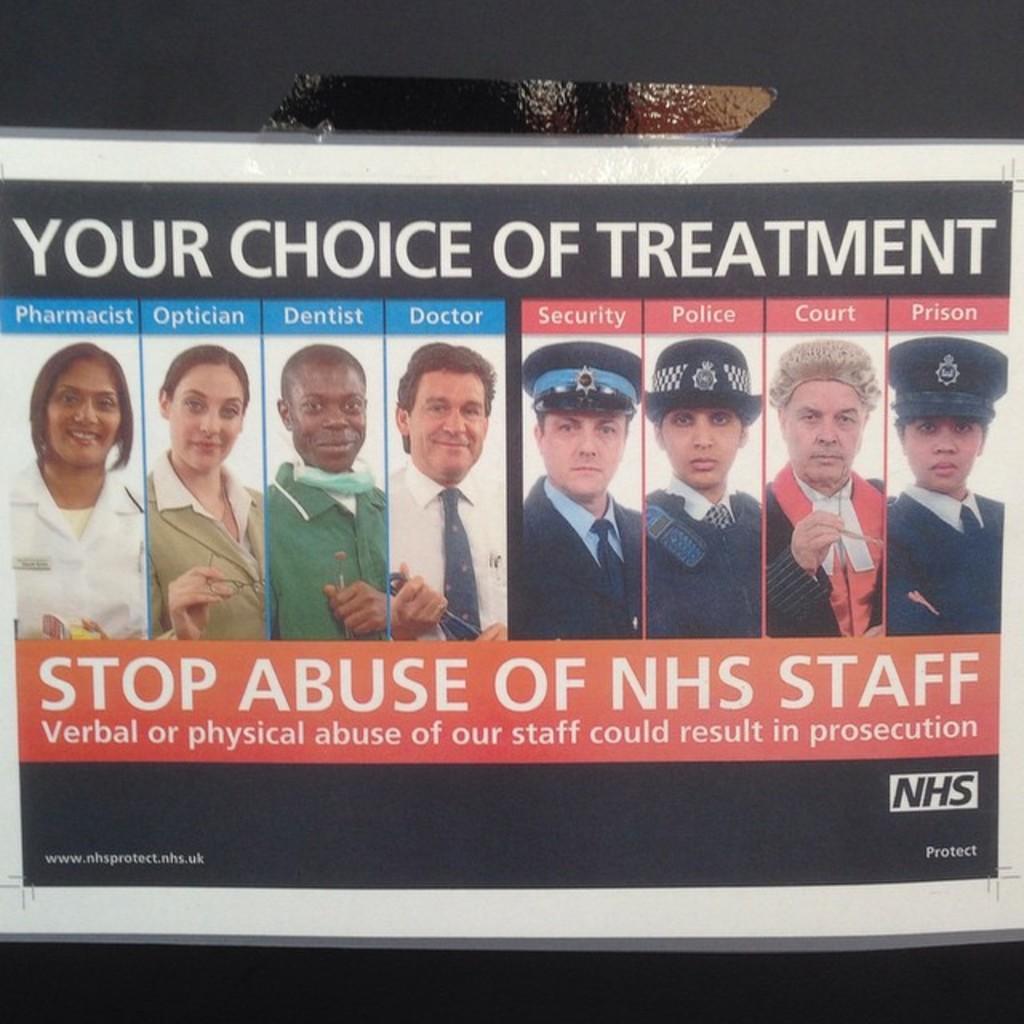How would you summarize this image in a sentence or two? This image consists of a poster in which there are images of many persons. At the bottom, there is a text. 